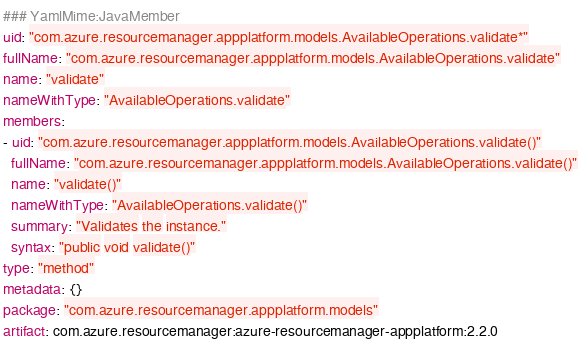Convert code to text. <code><loc_0><loc_0><loc_500><loc_500><_YAML_>### YamlMime:JavaMember
uid: "com.azure.resourcemanager.appplatform.models.AvailableOperations.validate*"
fullName: "com.azure.resourcemanager.appplatform.models.AvailableOperations.validate"
name: "validate"
nameWithType: "AvailableOperations.validate"
members:
- uid: "com.azure.resourcemanager.appplatform.models.AvailableOperations.validate()"
  fullName: "com.azure.resourcemanager.appplatform.models.AvailableOperations.validate()"
  name: "validate()"
  nameWithType: "AvailableOperations.validate()"
  summary: "Validates the instance."
  syntax: "public void validate()"
type: "method"
metadata: {}
package: "com.azure.resourcemanager.appplatform.models"
artifact: com.azure.resourcemanager:azure-resourcemanager-appplatform:2.2.0
</code> 